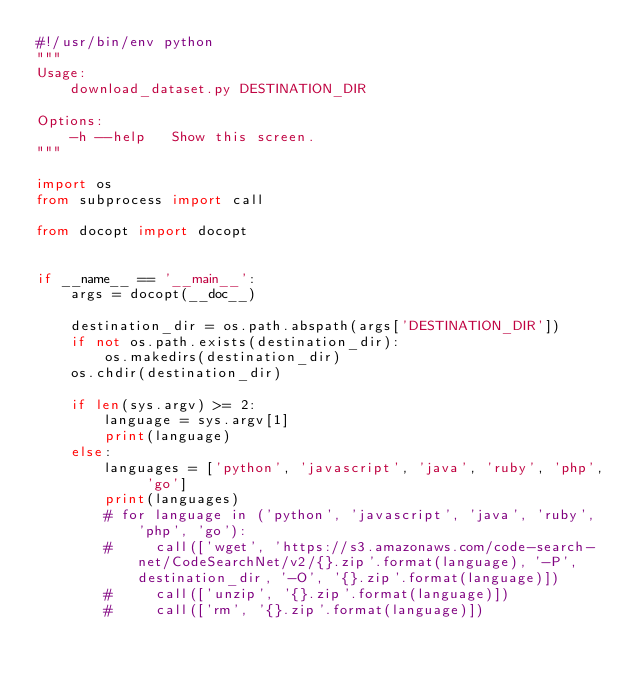<code> <loc_0><loc_0><loc_500><loc_500><_Python_>#!/usr/bin/env python
"""
Usage:
    download_dataset.py DESTINATION_DIR

Options:
    -h --help   Show this screen.
"""

import os
from subprocess import call

from docopt import docopt


if __name__ == '__main__':
    args = docopt(__doc__)

    destination_dir = os.path.abspath(args['DESTINATION_DIR'])
    if not os.path.exists(destination_dir):
        os.makedirs(destination_dir)
    os.chdir(destination_dir)

    if len(sys.argv) >= 2:
        language = sys.argv[1]
        print(language)
    else:
        languages = ['python', 'javascript', 'java', 'ruby', 'php', 'go']
        print(languages)
        # for language in ('python', 'javascript', 'java', 'ruby', 'php', 'go'):
        #     call(['wget', 'https://s3.amazonaws.com/code-search-net/CodeSearchNet/v2/{}.zip'.format(language), '-P', destination_dir, '-O', '{}.zip'.format(language)])
        #     call(['unzip', '{}.zip'.format(language)])
        #     call(['rm', '{}.zip'.format(language)])
</code> 